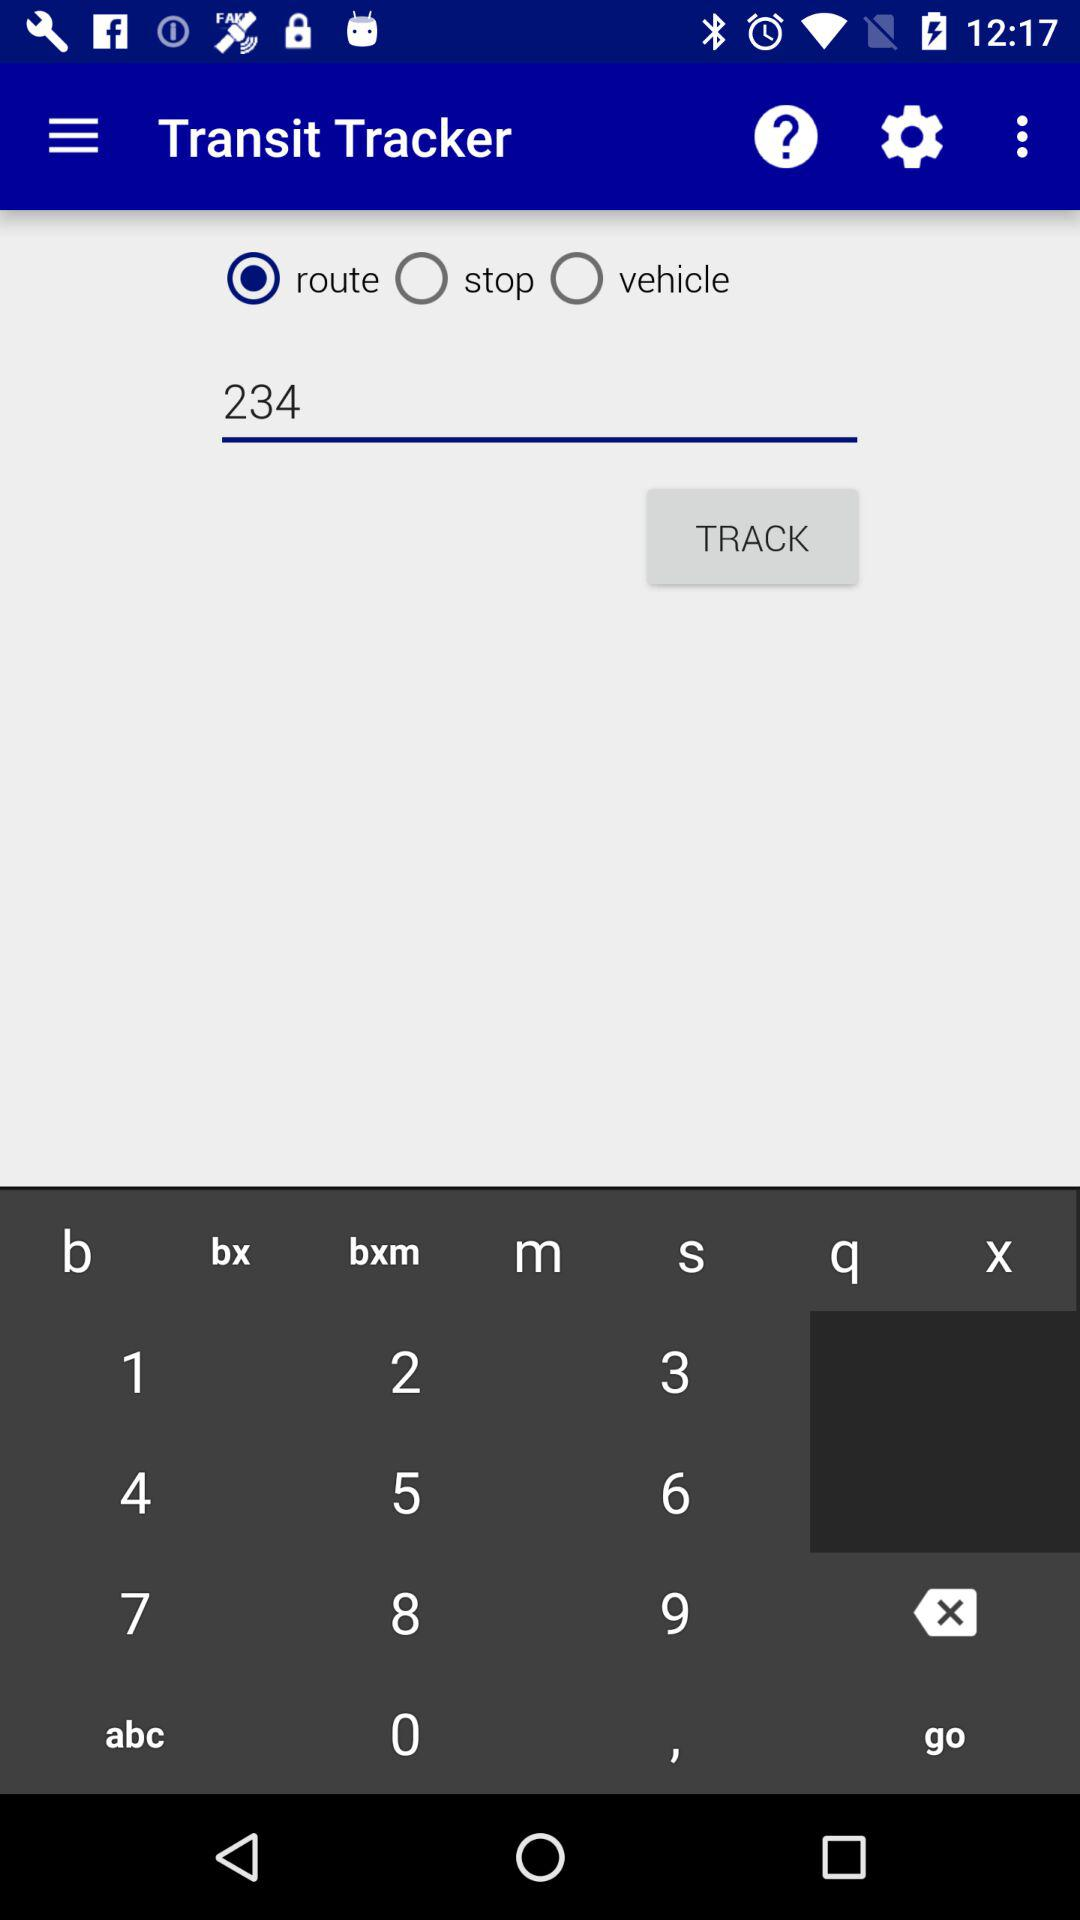What number is shown in the input field? The number is 234. 